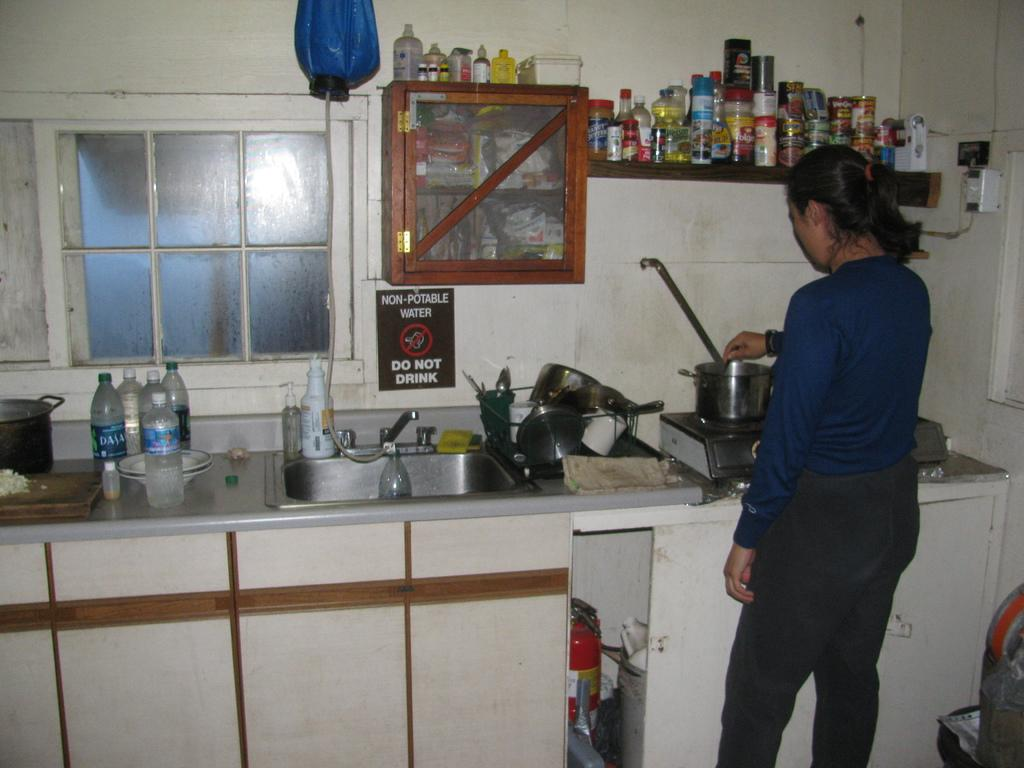<image>
Create a compact narrative representing the image presented. A woman is cooking in a kitchen that has a sign that warns that the water is not drinkable. 